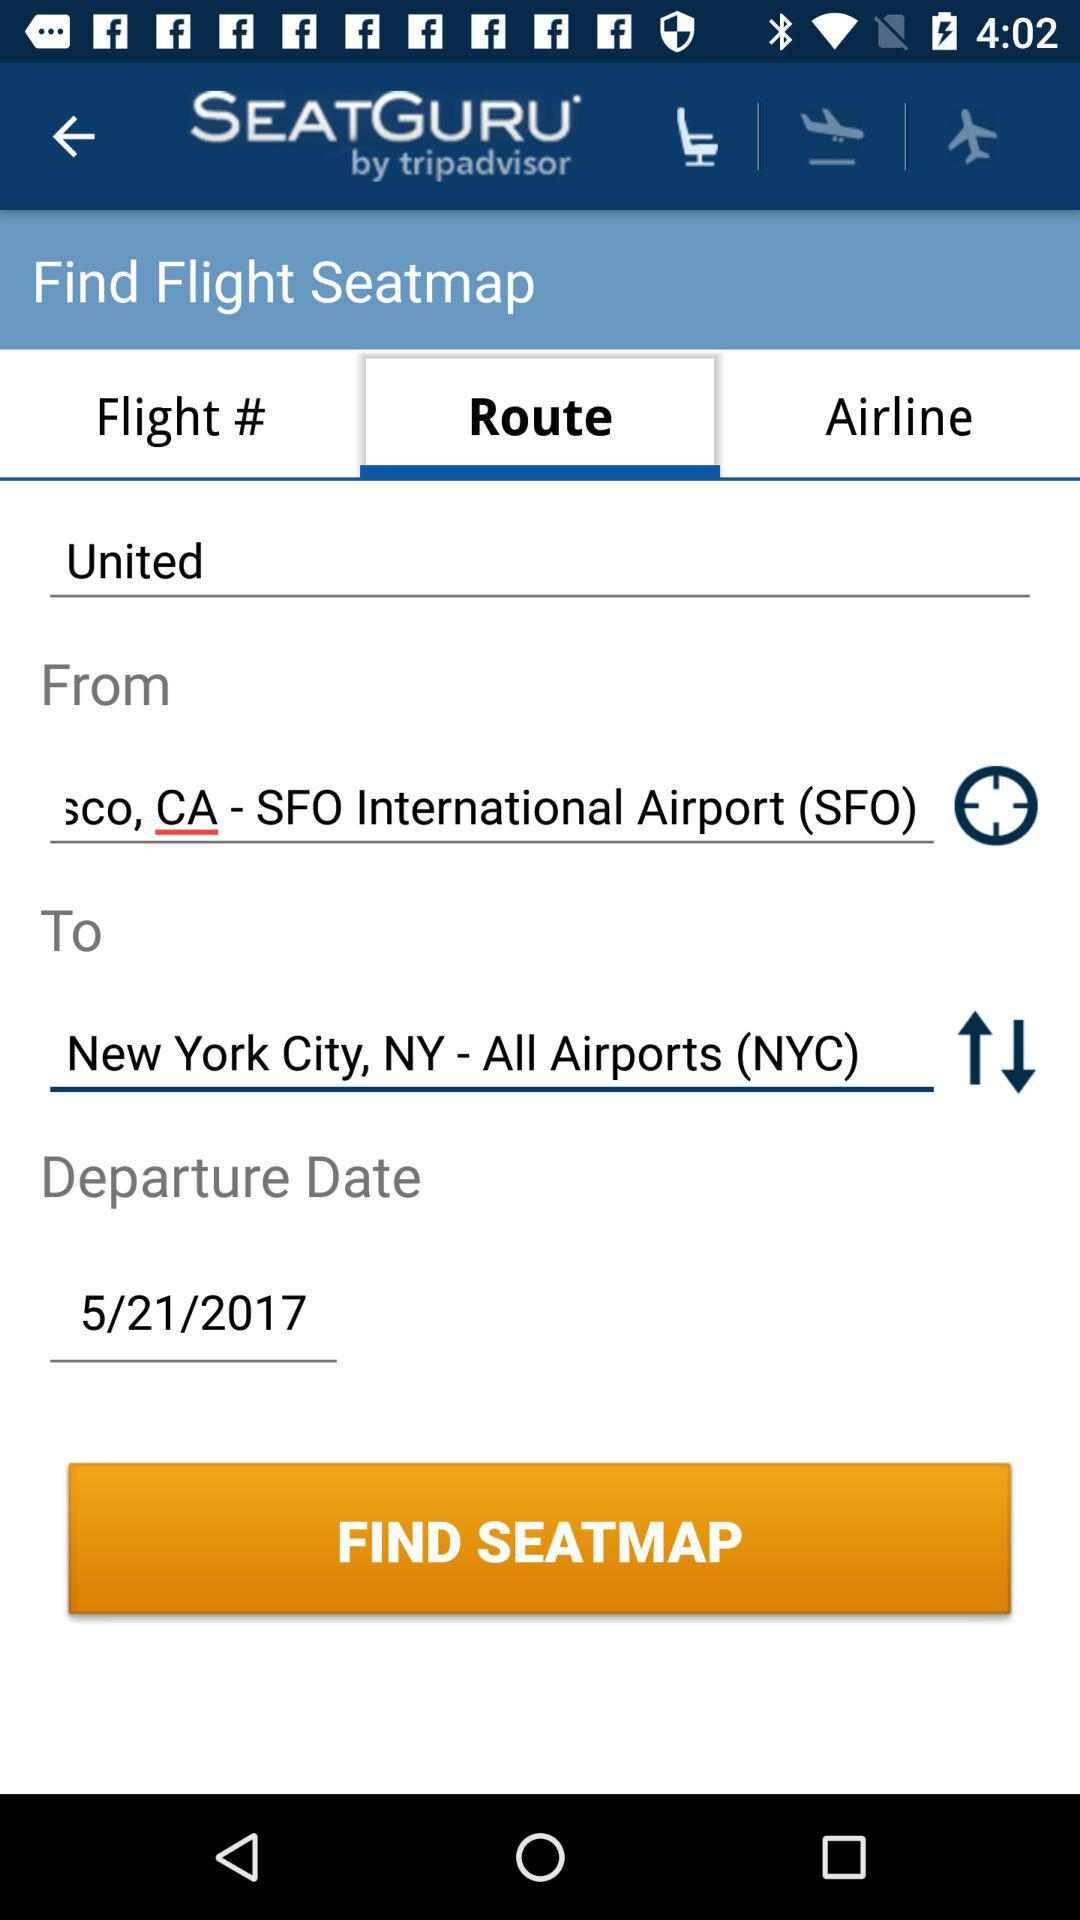What is the flight's destination? The flight's destination is New York City. 